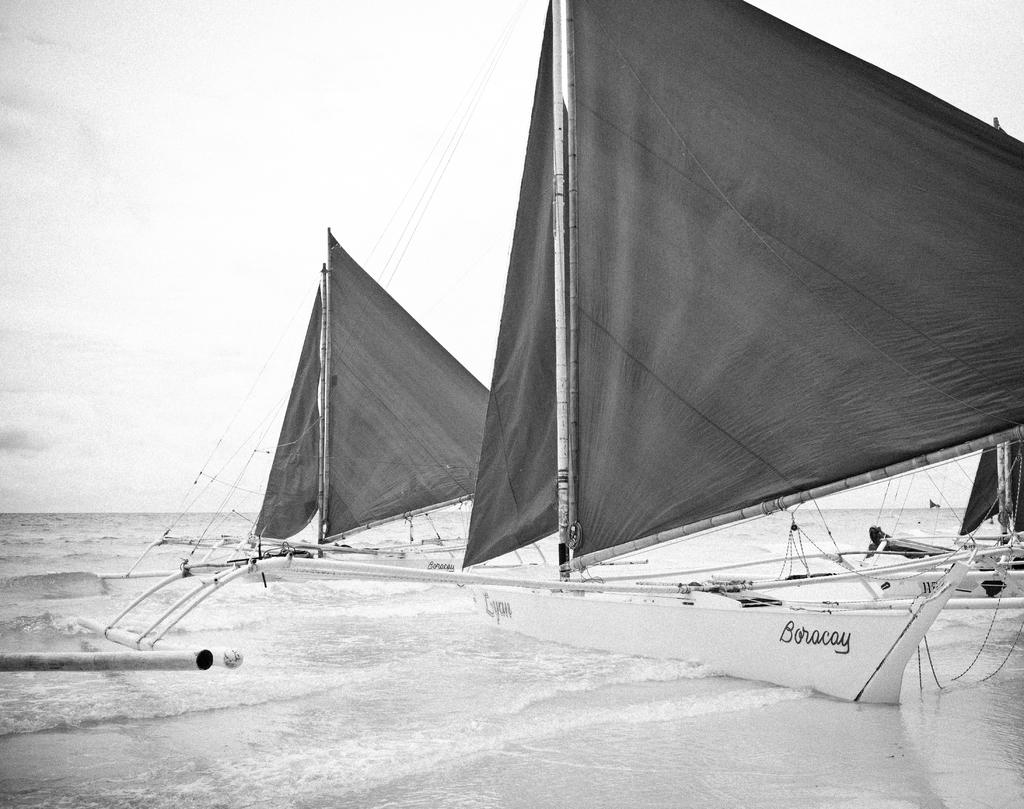What type of vehicles are in the image? There are boats in the image. Where are the boats located? The boats are on the ocean. What feature do the boats have? The boats have sails. What part of the natural environment is visible in the image? The sky is visible in the image. How is the image presented? The image is in black and white mode. Can you hear the sound of thunder in the image? There is no sound present in the image, so it is not possible to hear any thunder. 